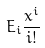<formula> <loc_0><loc_0><loc_500><loc_500>E _ { i } \frac { x ^ { i } } { i ! }</formula> 